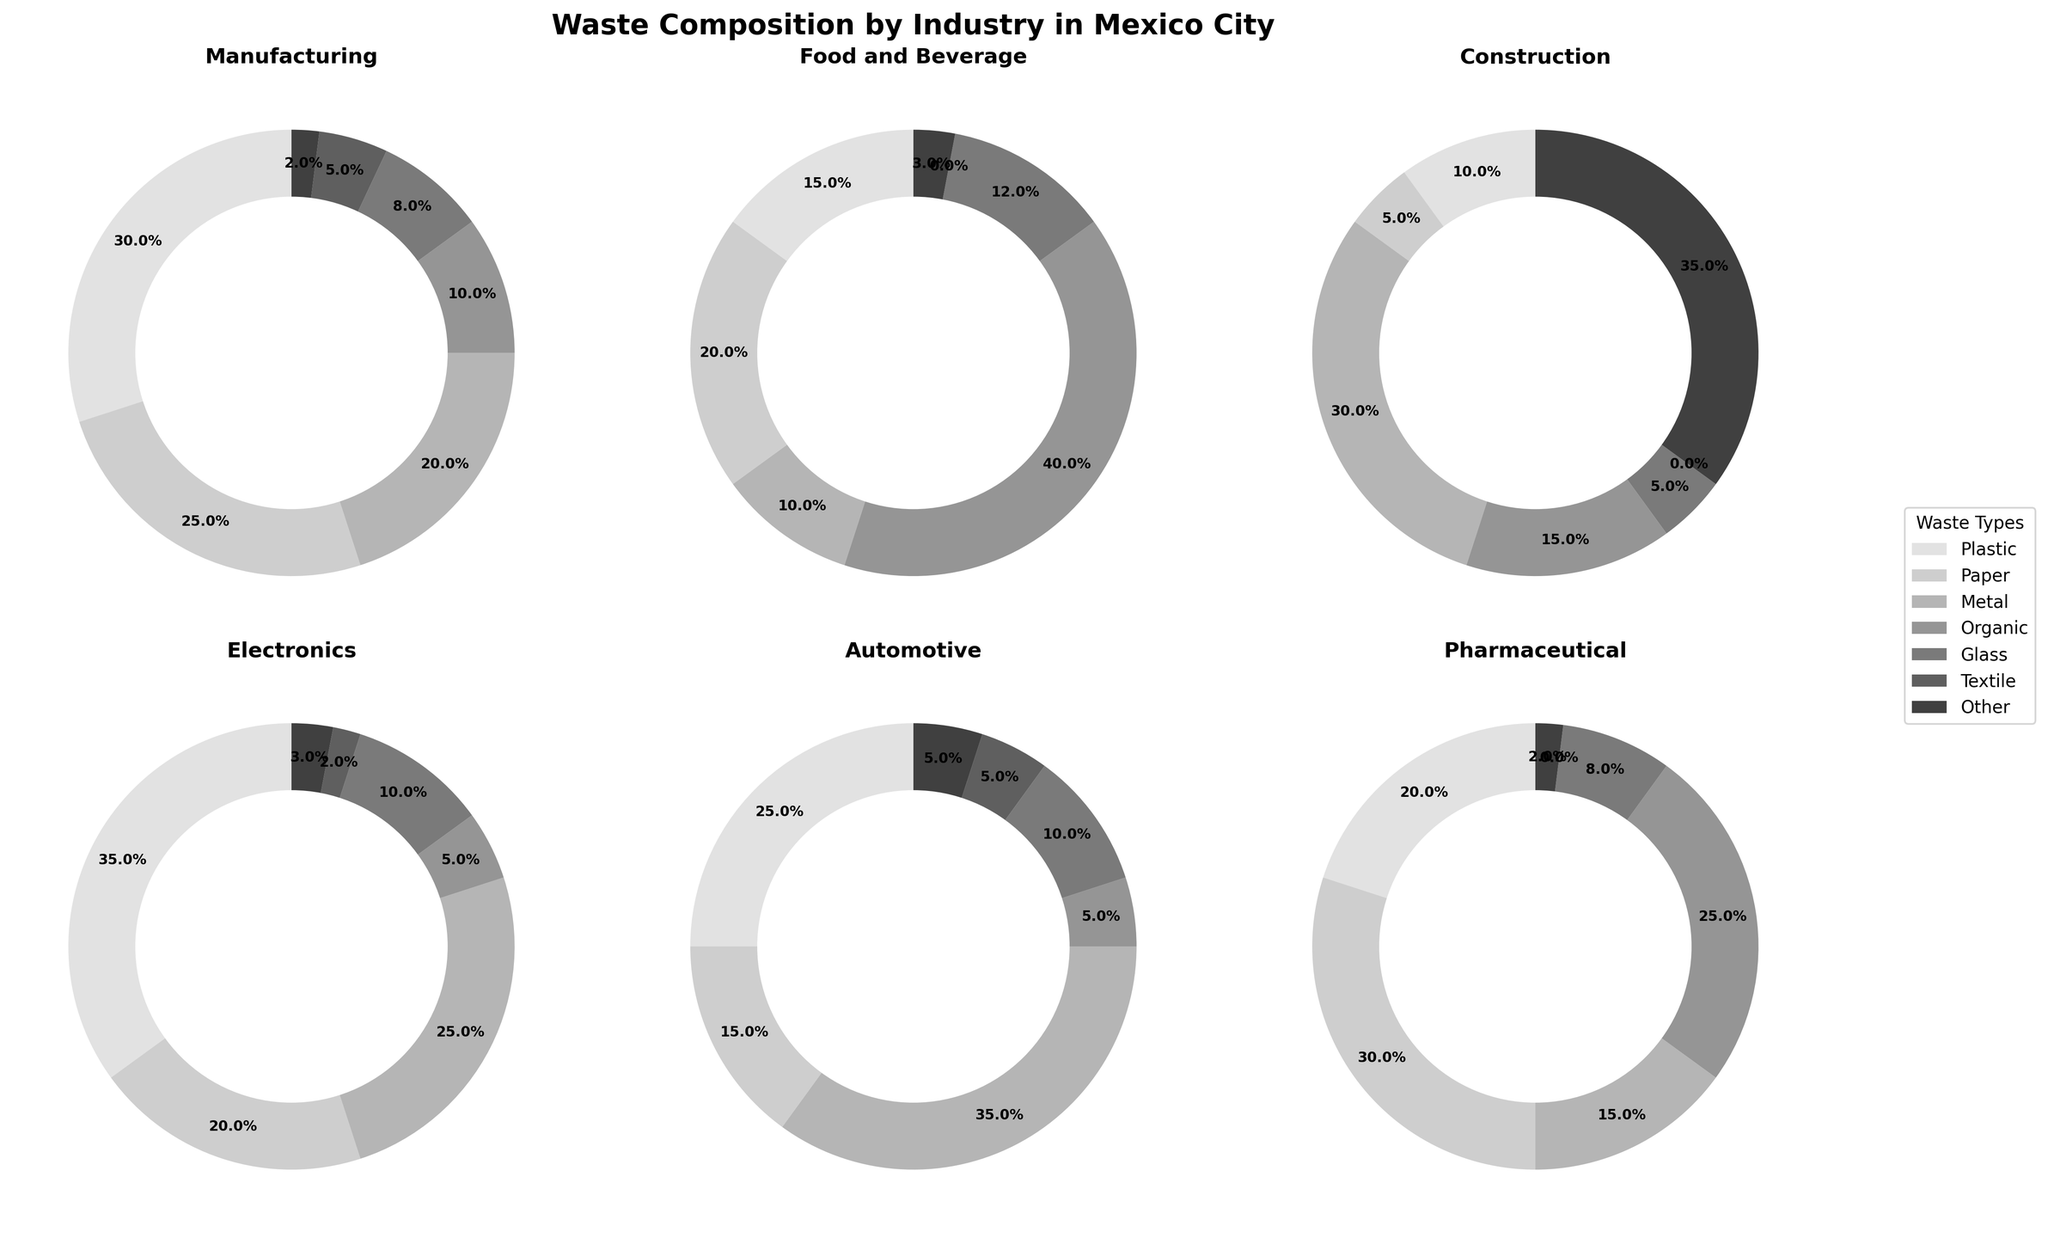Which industry generates the highest proportion of organic waste? The pie chart for each industry shows the proportions of different waste types. The Food and Beverage industry has the largest section labeled as organic waste, totaling 40%.
Answer: Food and Beverage What is the total percentage of waste composition attributed to metal in all industries combined? Calculate the sum of the percentages of metal waste across all industries (20% + 10% + 30% + 25% + 35% + 15%) = 135%. Therefore, the total percentage is 135% when summed across industries.
Answer: 135% Which industry has the smallest proportion of plastic waste? By observing each pie chart, the Construction industry has the smallest section labeled as plastic waste, which is 10%.
Answer: Construction In the Electronics industry, what is the combined percentage of plastic and metal waste? In the Electronics industry, plastic waste is 35% and metal waste is 25%. Sum these percentages: 35% + 25% = 60%.
Answer: 60% Compare the proportions of glass waste in the Automotive and Pharmaceutical industries. Which one has more and by how much? The Automotive industry has 10% glass waste, while the Pharmaceutical industry has 8% glass waste. The difference is 10% - 8% = 2%, so the Automotive industry has 2% more glass waste.
Answer: Automotive, 2% In which industry does 'Other' waste make up the highest proportion, and what is that proportion? From the pie charts, the Construction industry has the largest proportion of 'Other' waste, which is 35%.
Answer: Construction, 35% What is the average percentage of paper waste across all industries? Calculate the average by summing the paper percentages and dividing by the number of industries (25% + 20% + 5% + 20% + 15% + 30%) / 6 = 19.17%.
Answer: 19.17% Which industry has the smallest proportion of its waste as textile, and what is that percentage? Observe the pie charts to find that both the Food and Beverage, and Construction industries have 0% textile waste. Therefore, the percentage is 0%.
Answer: Food and Beverage, Construction, 0% Compare the Food and Beverage industry and the Electronics industry in terms of organic waste. Which one has the higher percentage, and by how much? The Food and Beverage industry has 40% organic waste, while the Electronics industry has 5% organic waste. The difference is 40% - 5% = 35%, so the Food and Beverage industry has 35% more organic waste.
Answer: Food and Beverage, 35% What percentage of waste in the Pharmaceutical industry is composed of organic and textile waste combined? In the Pharmaceutical industry, organic waste is 25% and textile waste is 0%. Sum these percentages: 25% + 0% = 25%.
Answer: 25% 